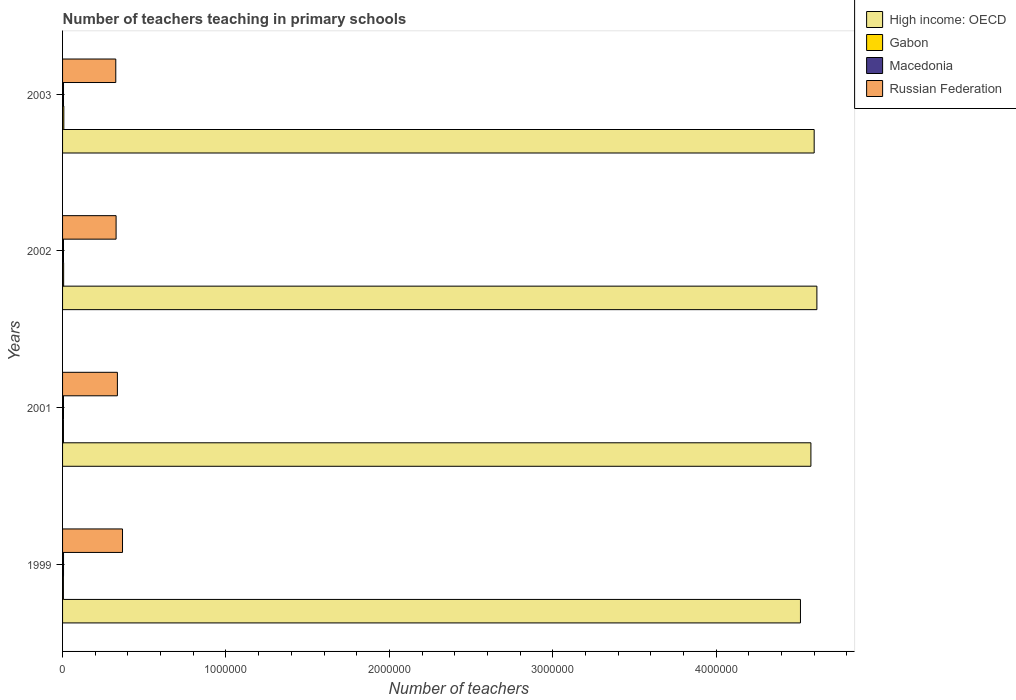How many different coloured bars are there?
Offer a very short reply. 4. Are the number of bars per tick equal to the number of legend labels?
Offer a terse response. Yes. How many bars are there on the 2nd tick from the top?
Offer a terse response. 4. What is the label of the 4th group of bars from the top?
Keep it short and to the point. 1999. In how many cases, is the number of bars for a given year not equal to the number of legend labels?
Make the answer very short. 0. What is the number of teachers teaching in primary schools in High income: OECD in 2001?
Your response must be concise. 4.58e+06. Across all years, what is the maximum number of teachers teaching in primary schools in Macedonia?
Ensure brevity in your answer.  5865. Across all years, what is the minimum number of teachers teaching in primary schools in Macedonia?
Offer a terse response. 5718. In which year was the number of teachers teaching in primary schools in Gabon maximum?
Make the answer very short. 2003. In which year was the number of teachers teaching in primary schools in Macedonia minimum?
Provide a short and direct response. 2002. What is the total number of teachers teaching in primary schools in High income: OECD in the graph?
Offer a terse response. 1.83e+07. What is the difference between the number of teachers teaching in primary schools in Gabon in 1999 and that in 2003?
Your response must be concise. -2657. What is the difference between the number of teachers teaching in primary schools in Macedonia in 2001 and the number of teachers teaching in primary schools in High income: OECD in 2002?
Provide a short and direct response. -4.61e+06. What is the average number of teachers teaching in primary schools in Macedonia per year?
Your answer should be compact. 5769.5. In the year 2003, what is the difference between the number of teachers teaching in primary schools in High income: OECD and number of teachers teaching in primary schools in Gabon?
Offer a terse response. 4.59e+06. In how many years, is the number of teachers teaching in primary schools in Gabon greater than 2400000 ?
Provide a short and direct response. 0. What is the ratio of the number of teachers teaching in primary schools in Gabon in 2001 to that in 2003?
Give a very brief answer. 0.7. Is the difference between the number of teachers teaching in primary schools in High income: OECD in 2002 and 2003 greater than the difference between the number of teachers teaching in primary schools in Gabon in 2002 and 2003?
Offer a very short reply. Yes. What is the difference between the highest and the lowest number of teachers teaching in primary schools in Gabon?
Give a very brief answer. 2657. Is the sum of the number of teachers teaching in primary schools in Gabon in 1999 and 2001 greater than the maximum number of teachers teaching in primary schools in High income: OECD across all years?
Your response must be concise. No. What does the 1st bar from the top in 2002 represents?
Keep it short and to the point. Russian Federation. What does the 1st bar from the bottom in 2001 represents?
Ensure brevity in your answer.  High income: OECD. Is it the case that in every year, the sum of the number of teachers teaching in primary schools in Gabon and number of teachers teaching in primary schools in Russian Federation is greater than the number of teachers teaching in primary schools in High income: OECD?
Keep it short and to the point. No. How many years are there in the graph?
Provide a short and direct response. 4. Does the graph contain grids?
Make the answer very short. No. Where does the legend appear in the graph?
Keep it short and to the point. Top right. What is the title of the graph?
Provide a short and direct response. Number of teachers teaching in primary schools. What is the label or title of the X-axis?
Offer a very short reply. Number of teachers. What is the Number of teachers in High income: OECD in 1999?
Give a very brief answer. 4.52e+06. What is the Number of teachers of Gabon in 1999?
Your response must be concise. 5107. What is the Number of teachers of Macedonia in 1999?
Your response must be concise. 5865. What is the Number of teachers in Russian Federation in 1999?
Your answer should be very brief. 3.67e+05. What is the Number of teachers in High income: OECD in 2001?
Provide a short and direct response. 4.58e+06. What is the Number of teachers in Gabon in 2001?
Give a very brief answer. 5399. What is the Number of teachers of Macedonia in 2001?
Provide a succinct answer. 5729. What is the Number of teachers of Russian Federation in 2001?
Offer a terse response. 3.36e+05. What is the Number of teachers of High income: OECD in 2002?
Your answer should be very brief. 4.62e+06. What is the Number of teachers of Gabon in 2002?
Provide a succinct answer. 6612. What is the Number of teachers of Macedonia in 2002?
Give a very brief answer. 5718. What is the Number of teachers in Russian Federation in 2002?
Ensure brevity in your answer.  3.28e+05. What is the Number of teachers of High income: OECD in 2003?
Offer a very short reply. 4.60e+06. What is the Number of teachers in Gabon in 2003?
Offer a very short reply. 7764. What is the Number of teachers of Macedonia in 2003?
Make the answer very short. 5766. What is the Number of teachers of Russian Federation in 2003?
Your response must be concise. 3.26e+05. Across all years, what is the maximum Number of teachers of High income: OECD?
Provide a short and direct response. 4.62e+06. Across all years, what is the maximum Number of teachers of Gabon?
Your response must be concise. 7764. Across all years, what is the maximum Number of teachers of Macedonia?
Keep it short and to the point. 5865. Across all years, what is the maximum Number of teachers in Russian Federation?
Offer a very short reply. 3.67e+05. Across all years, what is the minimum Number of teachers of High income: OECD?
Your answer should be compact. 4.52e+06. Across all years, what is the minimum Number of teachers in Gabon?
Give a very brief answer. 5107. Across all years, what is the minimum Number of teachers of Macedonia?
Provide a short and direct response. 5718. Across all years, what is the minimum Number of teachers of Russian Federation?
Your answer should be compact. 3.26e+05. What is the total Number of teachers in High income: OECD in the graph?
Give a very brief answer. 1.83e+07. What is the total Number of teachers in Gabon in the graph?
Your response must be concise. 2.49e+04. What is the total Number of teachers of Macedonia in the graph?
Make the answer very short. 2.31e+04. What is the total Number of teachers in Russian Federation in the graph?
Your response must be concise. 1.36e+06. What is the difference between the Number of teachers in High income: OECD in 1999 and that in 2001?
Give a very brief answer. -6.40e+04. What is the difference between the Number of teachers of Gabon in 1999 and that in 2001?
Make the answer very short. -292. What is the difference between the Number of teachers of Macedonia in 1999 and that in 2001?
Provide a short and direct response. 136. What is the difference between the Number of teachers in Russian Federation in 1999 and that in 2001?
Ensure brevity in your answer.  3.14e+04. What is the difference between the Number of teachers in High income: OECD in 1999 and that in 2002?
Provide a succinct answer. -1.01e+05. What is the difference between the Number of teachers in Gabon in 1999 and that in 2002?
Offer a terse response. -1505. What is the difference between the Number of teachers in Macedonia in 1999 and that in 2002?
Make the answer very short. 147. What is the difference between the Number of teachers of Russian Federation in 1999 and that in 2002?
Your response must be concise. 3.93e+04. What is the difference between the Number of teachers in High income: OECD in 1999 and that in 2003?
Offer a very short reply. -8.40e+04. What is the difference between the Number of teachers of Gabon in 1999 and that in 2003?
Provide a short and direct response. -2657. What is the difference between the Number of teachers in Macedonia in 1999 and that in 2003?
Offer a terse response. 99. What is the difference between the Number of teachers in Russian Federation in 1999 and that in 2003?
Your response must be concise. 4.12e+04. What is the difference between the Number of teachers in High income: OECD in 2001 and that in 2002?
Ensure brevity in your answer.  -3.66e+04. What is the difference between the Number of teachers of Gabon in 2001 and that in 2002?
Provide a short and direct response. -1213. What is the difference between the Number of teachers of Russian Federation in 2001 and that in 2002?
Keep it short and to the point. 7924. What is the difference between the Number of teachers in High income: OECD in 2001 and that in 2003?
Offer a terse response. -2.00e+04. What is the difference between the Number of teachers of Gabon in 2001 and that in 2003?
Your answer should be very brief. -2365. What is the difference between the Number of teachers of Macedonia in 2001 and that in 2003?
Offer a terse response. -37. What is the difference between the Number of teachers in Russian Federation in 2001 and that in 2003?
Your response must be concise. 9833. What is the difference between the Number of teachers in High income: OECD in 2002 and that in 2003?
Your answer should be very brief. 1.66e+04. What is the difference between the Number of teachers in Gabon in 2002 and that in 2003?
Provide a succinct answer. -1152. What is the difference between the Number of teachers in Macedonia in 2002 and that in 2003?
Your answer should be very brief. -48. What is the difference between the Number of teachers in Russian Federation in 2002 and that in 2003?
Your answer should be very brief. 1909. What is the difference between the Number of teachers of High income: OECD in 1999 and the Number of teachers of Gabon in 2001?
Make the answer very short. 4.51e+06. What is the difference between the Number of teachers in High income: OECD in 1999 and the Number of teachers in Macedonia in 2001?
Your answer should be compact. 4.51e+06. What is the difference between the Number of teachers of High income: OECD in 1999 and the Number of teachers of Russian Federation in 2001?
Offer a very short reply. 4.18e+06. What is the difference between the Number of teachers of Gabon in 1999 and the Number of teachers of Macedonia in 2001?
Make the answer very short. -622. What is the difference between the Number of teachers in Gabon in 1999 and the Number of teachers in Russian Federation in 2001?
Provide a short and direct response. -3.30e+05. What is the difference between the Number of teachers of Macedonia in 1999 and the Number of teachers of Russian Federation in 2001?
Your answer should be very brief. -3.30e+05. What is the difference between the Number of teachers in High income: OECD in 1999 and the Number of teachers in Gabon in 2002?
Your response must be concise. 4.51e+06. What is the difference between the Number of teachers in High income: OECD in 1999 and the Number of teachers in Macedonia in 2002?
Provide a short and direct response. 4.51e+06. What is the difference between the Number of teachers of High income: OECD in 1999 and the Number of teachers of Russian Federation in 2002?
Offer a terse response. 4.19e+06. What is the difference between the Number of teachers in Gabon in 1999 and the Number of teachers in Macedonia in 2002?
Your answer should be very brief. -611. What is the difference between the Number of teachers in Gabon in 1999 and the Number of teachers in Russian Federation in 2002?
Give a very brief answer. -3.22e+05. What is the difference between the Number of teachers in Macedonia in 1999 and the Number of teachers in Russian Federation in 2002?
Ensure brevity in your answer.  -3.22e+05. What is the difference between the Number of teachers in High income: OECD in 1999 and the Number of teachers in Gabon in 2003?
Provide a succinct answer. 4.51e+06. What is the difference between the Number of teachers in High income: OECD in 1999 and the Number of teachers in Macedonia in 2003?
Provide a short and direct response. 4.51e+06. What is the difference between the Number of teachers of High income: OECD in 1999 and the Number of teachers of Russian Federation in 2003?
Your answer should be compact. 4.19e+06. What is the difference between the Number of teachers in Gabon in 1999 and the Number of teachers in Macedonia in 2003?
Your answer should be very brief. -659. What is the difference between the Number of teachers in Gabon in 1999 and the Number of teachers in Russian Federation in 2003?
Make the answer very short. -3.21e+05. What is the difference between the Number of teachers in Macedonia in 1999 and the Number of teachers in Russian Federation in 2003?
Give a very brief answer. -3.20e+05. What is the difference between the Number of teachers in High income: OECD in 2001 and the Number of teachers in Gabon in 2002?
Your response must be concise. 4.57e+06. What is the difference between the Number of teachers in High income: OECD in 2001 and the Number of teachers in Macedonia in 2002?
Offer a very short reply. 4.57e+06. What is the difference between the Number of teachers of High income: OECD in 2001 and the Number of teachers of Russian Federation in 2002?
Offer a terse response. 4.25e+06. What is the difference between the Number of teachers of Gabon in 2001 and the Number of teachers of Macedonia in 2002?
Give a very brief answer. -319. What is the difference between the Number of teachers in Gabon in 2001 and the Number of teachers in Russian Federation in 2002?
Make the answer very short. -3.22e+05. What is the difference between the Number of teachers in Macedonia in 2001 and the Number of teachers in Russian Federation in 2002?
Offer a very short reply. -3.22e+05. What is the difference between the Number of teachers of High income: OECD in 2001 and the Number of teachers of Gabon in 2003?
Your answer should be compact. 4.57e+06. What is the difference between the Number of teachers in High income: OECD in 2001 and the Number of teachers in Macedonia in 2003?
Keep it short and to the point. 4.57e+06. What is the difference between the Number of teachers in High income: OECD in 2001 and the Number of teachers in Russian Federation in 2003?
Your answer should be compact. 4.25e+06. What is the difference between the Number of teachers of Gabon in 2001 and the Number of teachers of Macedonia in 2003?
Give a very brief answer. -367. What is the difference between the Number of teachers in Gabon in 2001 and the Number of teachers in Russian Federation in 2003?
Your response must be concise. -3.20e+05. What is the difference between the Number of teachers of Macedonia in 2001 and the Number of teachers of Russian Federation in 2003?
Your response must be concise. -3.20e+05. What is the difference between the Number of teachers of High income: OECD in 2002 and the Number of teachers of Gabon in 2003?
Give a very brief answer. 4.61e+06. What is the difference between the Number of teachers of High income: OECD in 2002 and the Number of teachers of Macedonia in 2003?
Offer a terse response. 4.61e+06. What is the difference between the Number of teachers of High income: OECD in 2002 and the Number of teachers of Russian Federation in 2003?
Offer a very short reply. 4.29e+06. What is the difference between the Number of teachers of Gabon in 2002 and the Number of teachers of Macedonia in 2003?
Keep it short and to the point. 846. What is the difference between the Number of teachers of Gabon in 2002 and the Number of teachers of Russian Federation in 2003?
Give a very brief answer. -3.19e+05. What is the difference between the Number of teachers of Macedonia in 2002 and the Number of teachers of Russian Federation in 2003?
Your response must be concise. -3.20e+05. What is the average Number of teachers of High income: OECD per year?
Your answer should be compact. 4.58e+06. What is the average Number of teachers of Gabon per year?
Ensure brevity in your answer.  6220.5. What is the average Number of teachers of Macedonia per year?
Your answer should be very brief. 5769.5. What is the average Number of teachers in Russian Federation per year?
Keep it short and to the point. 3.39e+05. In the year 1999, what is the difference between the Number of teachers of High income: OECD and Number of teachers of Gabon?
Offer a very short reply. 4.51e+06. In the year 1999, what is the difference between the Number of teachers in High income: OECD and Number of teachers in Macedonia?
Your answer should be very brief. 4.51e+06. In the year 1999, what is the difference between the Number of teachers of High income: OECD and Number of teachers of Russian Federation?
Ensure brevity in your answer.  4.15e+06. In the year 1999, what is the difference between the Number of teachers of Gabon and Number of teachers of Macedonia?
Provide a succinct answer. -758. In the year 1999, what is the difference between the Number of teachers in Gabon and Number of teachers in Russian Federation?
Offer a terse response. -3.62e+05. In the year 1999, what is the difference between the Number of teachers in Macedonia and Number of teachers in Russian Federation?
Offer a very short reply. -3.61e+05. In the year 2001, what is the difference between the Number of teachers of High income: OECD and Number of teachers of Gabon?
Provide a succinct answer. 4.57e+06. In the year 2001, what is the difference between the Number of teachers of High income: OECD and Number of teachers of Macedonia?
Make the answer very short. 4.57e+06. In the year 2001, what is the difference between the Number of teachers of High income: OECD and Number of teachers of Russian Federation?
Keep it short and to the point. 4.24e+06. In the year 2001, what is the difference between the Number of teachers in Gabon and Number of teachers in Macedonia?
Provide a short and direct response. -330. In the year 2001, what is the difference between the Number of teachers of Gabon and Number of teachers of Russian Federation?
Provide a succinct answer. -3.30e+05. In the year 2001, what is the difference between the Number of teachers of Macedonia and Number of teachers of Russian Federation?
Provide a short and direct response. -3.30e+05. In the year 2002, what is the difference between the Number of teachers of High income: OECD and Number of teachers of Gabon?
Your answer should be very brief. 4.61e+06. In the year 2002, what is the difference between the Number of teachers of High income: OECD and Number of teachers of Macedonia?
Ensure brevity in your answer.  4.61e+06. In the year 2002, what is the difference between the Number of teachers of High income: OECD and Number of teachers of Russian Federation?
Give a very brief answer. 4.29e+06. In the year 2002, what is the difference between the Number of teachers in Gabon and Number of teachers in Macedonia?
Make the answer very short. 894. In the year 2002, what is the difference between the Number of teachers of Gabon and Number of teachers of Russian Federation?
Your response must be concise. -3.21e+05. In the year 2002, what is the difference between the Number of teachers in Macedonia and Number of teachers in Russian Federation?
Your answer should be compact. -3.22e+05. In the year 2003, what is the difference between the Number of teachers in High income: OECD and Number of teachers in Gabon?
Keep it short and to the point. 4.59e+06. In the year 2003, what is the difference between the Number of teachers in High income: OECD and Number of teachers in Macedonia?
Provide a short and direct response. 4.59e+06. In the year 2003, what is the difference between the Number of teachers of High income: OECD and Number of teachers of Russian Federation?
Give a very brief answer. 4.27e+06. In the year 2003, what is the difference between the Number of teachers of Gabon and Number of teachers of Macedonia?
Keep it short and to the point. 1998. In the year 2003, what is the difference between the Number of teachers of Gabon and Number of teachers of Russian Federation?
Ensure brevity in your answer.  -3.18e+05. In the year 2003, what is the difference between the Number of teachers in Macedonia and Number of teachers in Russian Federation?
Your answer should be very brief. -3.20e+05. What is the ratio of the Number of teachers of High income: OECD in 1999 to that in 2001?
Make the answer very short. 0.99. What is the ratio of the Number of teachers of Gabon in 1999 to that in 2001?
Provide a short and direct response. 0.95. What is the ratio of the Number of teachers of Macedonia in 1999 to that in 2001?
Make the answer very short. 1.02. What is the ratio of the Number of teachers of Russian Federation in 1999 to that in 2001?
Provide a short and direct response. 1.09. What is the ratio of the Number of teachers in High income: OECD in 1999 to that in 2002?
Your answer should be compact. 0.98. What is the ratio of the Number of teachers in Gabon in 1999 to that in 2002?
Provide a succinct answer. 0.77. What is the ratio of the Number of teachers of Macedonia in 1999 to that in 2002?
Provide a short and direct response. 1.03. What is the ratio of the Number of teachers of Russian Federation in 1999 to that in 2002?
Offer a very short reply. 1.12. What is the ratio of the Number of teachers in High income: OECD in 1999 to that in 2003?
Provide a short and direct response. 0.98. What is the ratio of the Number of teachers in Gabon in 1999 to that in 2003?
Your answer should be compact. 0.66. What is the ratio of the Number of teachers of Macedonia in 1999 to that in 2003?
Your answer should be compact. 1.02. What is the ratio of the Number of teachers of Russian Federation in 1999 to that in 2003?
Ensure brevity in your answer.  1.13. What is the ratio of the Number of teachers of High income: OECD in 2001 to that in 2002?
Offer a very short reply. 0.99. What is the ratio of the Number of teachers of Gabon in 2001 to that in 2002?
Provide a short and direct response. 0.82. What is the ratio of the Number of teachers in Macedonia in 2001 to that in 2002?
Provide a succinct answer. 1. What is the ratio of the Number of teachers in Russian Federation in 2001 to that in 2002?
Provide a succinct answer. 1.02. What is the ratio of the Number of teachers of High income: OECD in 2001 to that in 2003?
Provide a short and direct response. 1. What is the ratio of the Number of teachers in Gabon in 2001 to that in 2003?
Keep it short and to the point. 0.7. What is the ratio of the Number of teachers in Russian Federation in 2001 to that in 2003?
Provide a succinct answer. 1.03. What is the ratio of the Number of teachers of High income: OECD in 2002 to that in 2003?
Your answer should be compact. 1. What is the ratio of the Number of teachers in Gabon in 2002 to that in 2003?
Offer a terse response. 0.85. What is the ratio of the Number of teachers of Russian Federation in 2002 to that in 2003?
Make the answer very short. 1.01. What is the difference between the highest and the second highest Number of teachers of High income: OECD?
Offer a very short reply. 1.66e+04. What is the difference between the highest and the second highest Number of teachers in Gabon?
Offer a very short reply. 1152. What is the difference between the highest and the second highest Number of teachers in Russian Federation?
Give a very brief answer. 3.14e+04. What is the difference between the highest and the lowest Number of teachers of High income: OECD?
Provide a short and direct response. 1.01e+05. What is the difference between the highest and the lowest Number of teachers in Gabon?
Ensure brevity in your answer.  2657. What is the difference between the highest and the lowest Number of teachers of Macedonia?
Provide a succinct answer. 147. What is the difference between the highest and the lowest Number of teachers in Russian Federation?
Your answer should be compact. 4.12e+04. 